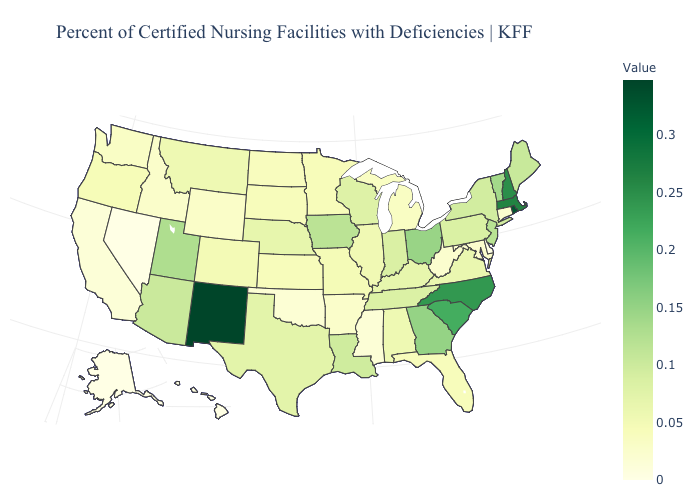Is the legend a continuous bar?
Short answer required. Yes. Does Rhode Island have the lowest value in the Northeast?
Short answer required. No. Does Alaska have the lowest value in the USA?
Quick response, please. Yes. Among the states that border Massachusetts , does Rhode Island have the highest value?
Give a very brief answer. Yes. Which states have the highest value in the USA?
Short answer required. New Mexico. Does Rhode Island have the highest value in the USA?
Concise answer only. No. Among the states that border California , which have the lowest value?
Keep it brief. Nevada. Is the legend a continuous bar?
Answer briefly. Yes. 